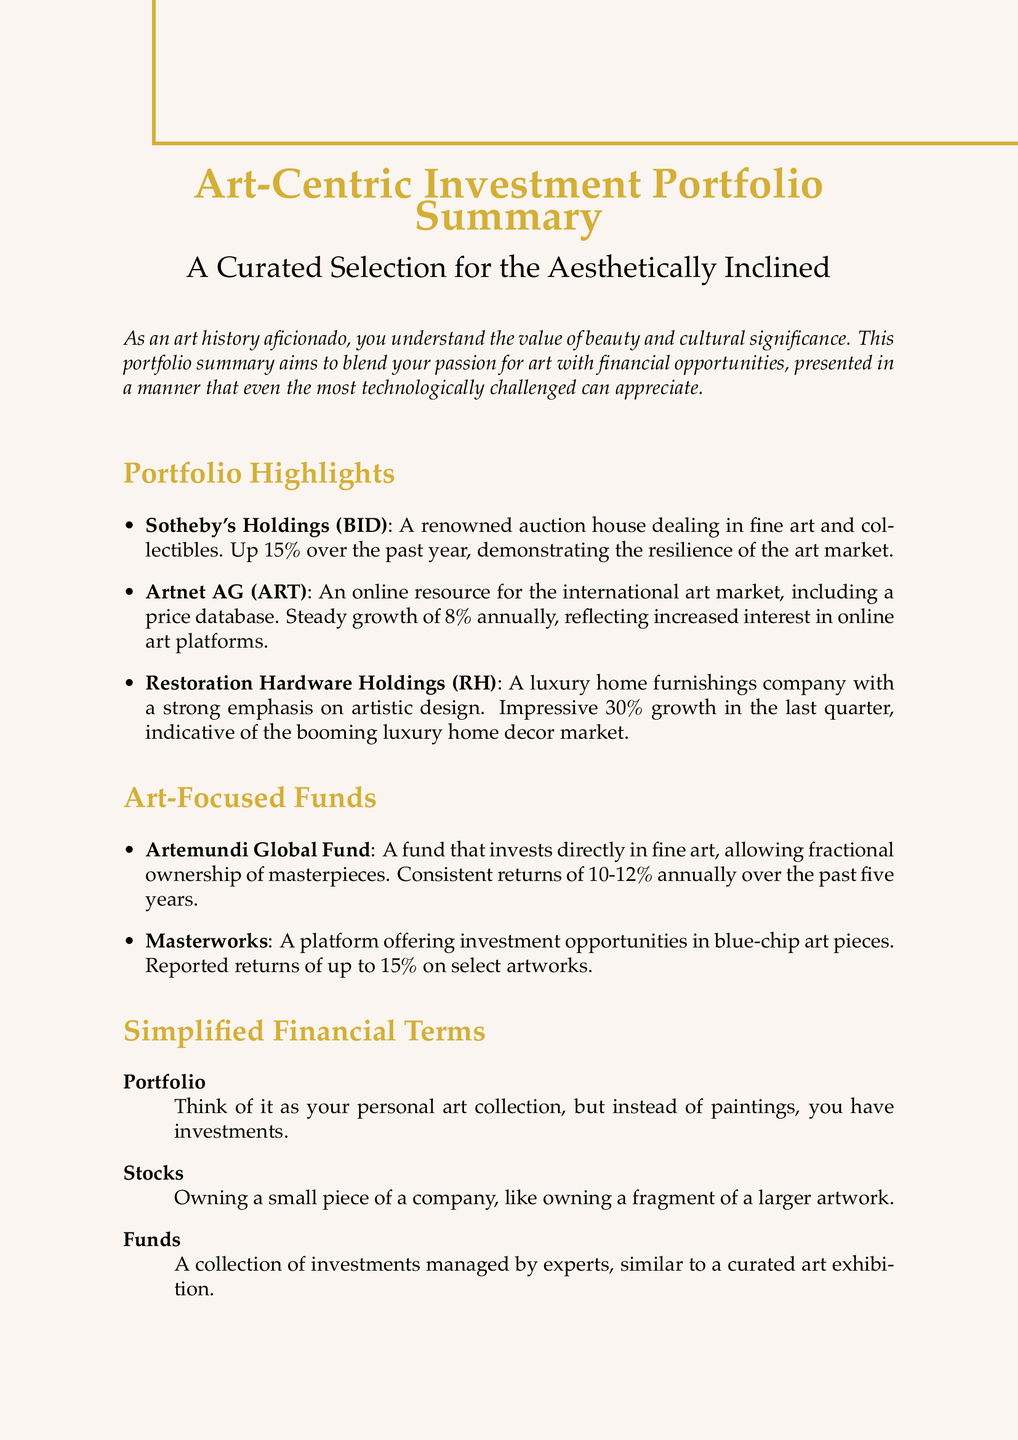What is the title of the document? The title refers to the main heading of the document, which is stated at the beginning.
Answer: Art-Centric Investment Portfolio Summary What percentage did Sotheby's Holdings grow over the past year? This information is provided under the performance highlights of Sotheby's Holdings in the document.
Answer: Up 15% What is the focus of the Artemundi Global Fund? The description of the fund indicates its main area of investment.
Answer: Fine art What was the growth percentage of Restoration Hardware Holdings in the last quarter? The performance section mentions the specific growth figure for Restoration Hardware Holdings.
Answer: 30% What is the average annual return range for the Artemundi Global Fund over the past five years? This information can be gathered from the performance details of the fund in the document.
Answer: 10-12% What type of collection do funds resemble according to the document? The explanation provided for funds in the section on simplified financial terms gives this comparison.
Answer: Curated art exhibition What does owning stocks represent metaphorically? The simplified explanation for stocks relates ownership to a familiar concept from art.
Answer: Owning a fragment of a larger artwork What aesthetic is emphasized by Restoration Hardware Holdings? The document describes the business approach of Restoration Hardware Holdings.
Answer: Artistic design 